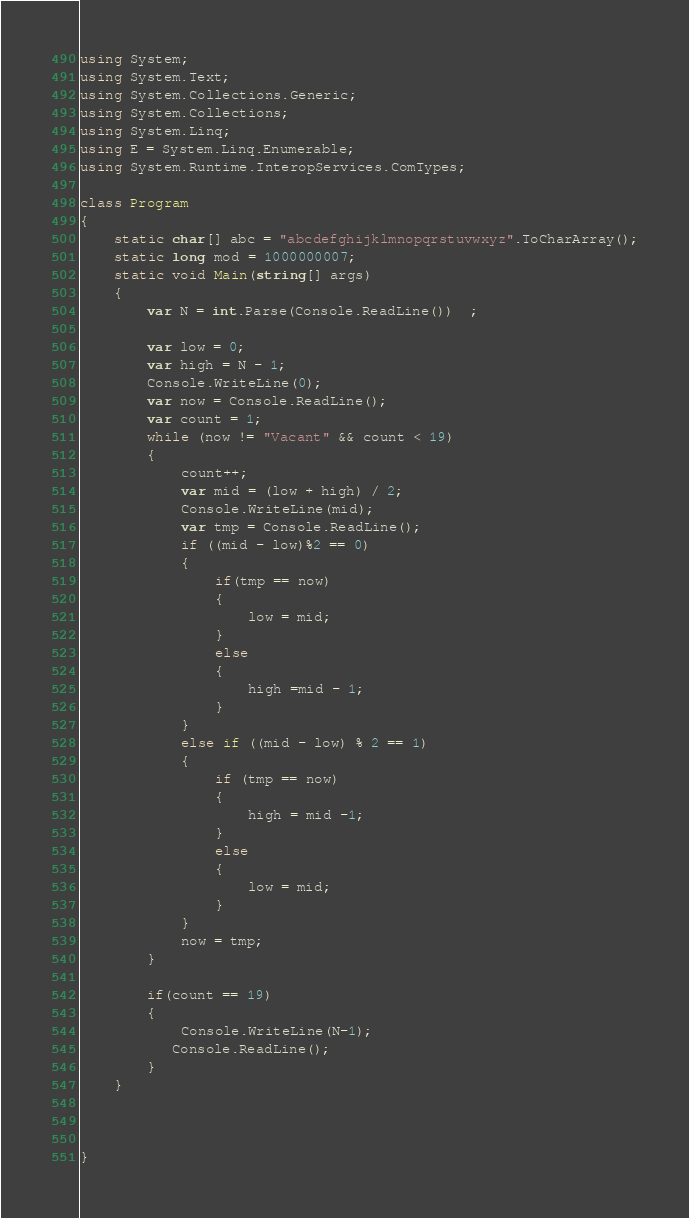Convert code to text. <code><loc_0><loc_0><loc_500><loc_500><_C#_>using System;
using System.Text;
using System.Collections.Generic;
using System.Collections;
using System.Linq;
using E = System.Linq.Enumerable;
using System.Runtime.InteropServices.ComTypes;

class Program
{
    static char[] abc = "abcdefghijklmnopqrstuvwxyz".ToCharArray();
    static long mod = 1000000007;
    static void Main(string[] args)
    {
        var N = int.Parse(Console.ReadLine())  ;

        var low = 0;
        var high = N - 1;
        Console.WriteLine(0);
        var now = Console.ReadLine();
        var count = 1;
        while (now != "Vacant" && count < 19)
        {
            count++;
            var mid = (low + high) / 2;
            Console.WriteLine(mid);
            var tmp = Console.ReadLine();
            if ((mid - low)%2 == 0)
            {
                if(tmp == now)
                {
                    low = mid;
                }
                else
                {
                    high =mid - 1;
                }
            }
            else if ((mid - low) % 2 == 1)
            {
                if (tmp == now)
                {
                    high = mid -1;
                }
                else
                {
                    low = mid;
                }
            }
            now = tmp;
        }

        if(count == 19)
        {
            Console.WriteLine(N-1);
           Console.ReadLine();
        }
    }



}
</code> 